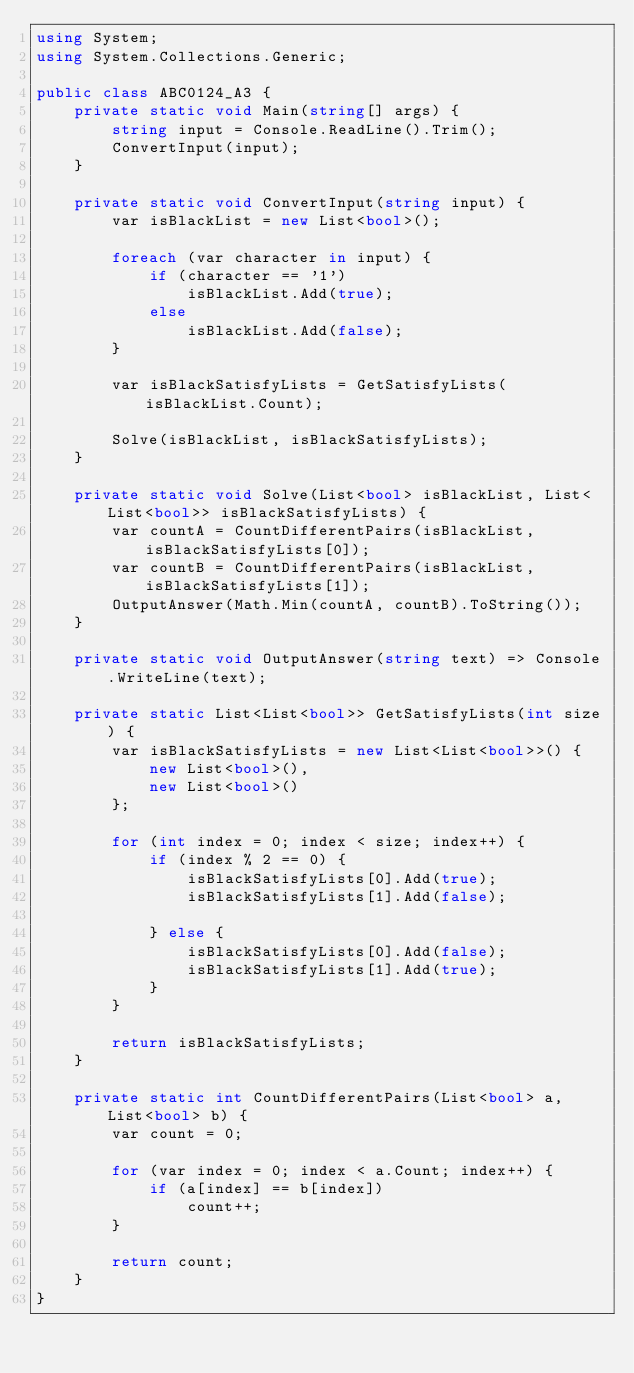Convert code to text. <code><loc_0><loc_0><loc_500><loc_500><_C#_>using System;
using System.Collections.Generic;

public class ABC0124_A3 {
    private static void Main(string[] args) {
        string input = Console.ReadLine().Trim();
        ConvertInput(input);
    }

    private static void ConvertInput(string input) {
        var isBlackList = new List<bool>();

        foreach (var character in input) {
            if (character == '1')
                isBlackList.Add(true);
            else
                isBlackList.Add(false);
        }

        var isBlackSatisfyLists = GetSatisfyLists(isBlackList.Count);

        Solve(isBlackList, isBlackSatisfyLists);
    }

    private static void Solve(List<bool> isBlackList, List<List<bool>> isBlackSatisfyLists) {
        var countA = CountDifferentPairs(isBlackList, isBlackSatisfyLists[0]);
        var countB = CountDifferentPairs(isBlackList, isBlackSatisfyLists[1]);
        OutputAnswer(Math.Min(countA, countB).ToString());
    }

    private static void OutputAnswer(string text) => Console.WriteLine(text);

    private static List<List<bool>> GetSatisfyLists(int size) {
        var isBlackSatisfyLists = new List<List<bool>>() {
            new List<bool>(),
            new List<bool>()
        };

        for (int index = 0; index < size; index++) {
            if (index % 2 == 0) {
                isBlackSatisfyLists[0].Add(true);
                isBlackSatisfyLists[1].Add(false);

            } else {
                isBlackSatisfyLists[0].Add(false);
                isBlackSatisfyLists[1].Add(true);
            }
        }

        return isBlackSatisfyLists;
    }

    private static int CountDifferentPairs(List<bool> a, List<bool> b) {
        var count = 0;

        for (var index = 0; index < a.Count; index++) {
            if (a[index] == b[index])
                count++;
        }

        return count;
    }
}</code> 